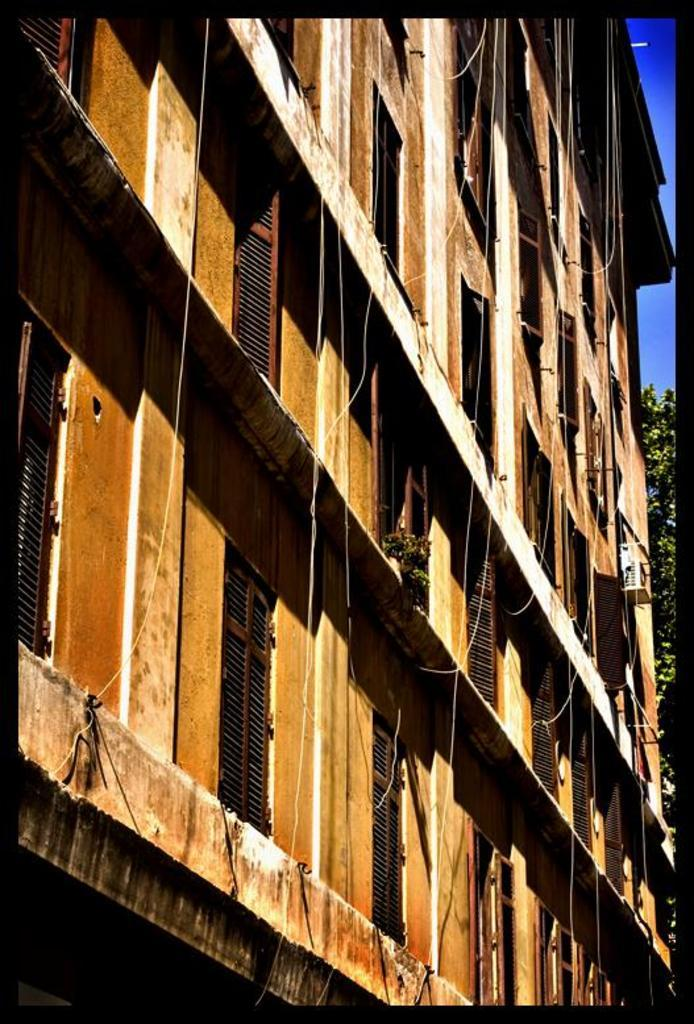What type of structure is present in the image? There is a building in the image. What feature can be seen on the building? The building has windows. What natural element is present in the image? There is a tree in the image. What device is visible in the image? An air conditioning unit (AC) is visible in the image. What can be seen in the background of the image? The sky is visible in the background of the image. What type of government is depicted in the image? There is no depiction of a government in the image; it features a building, a tree, an air conditioning unit, and the sky. What alarm is ringing in the image? There is no alarm present in the image. 